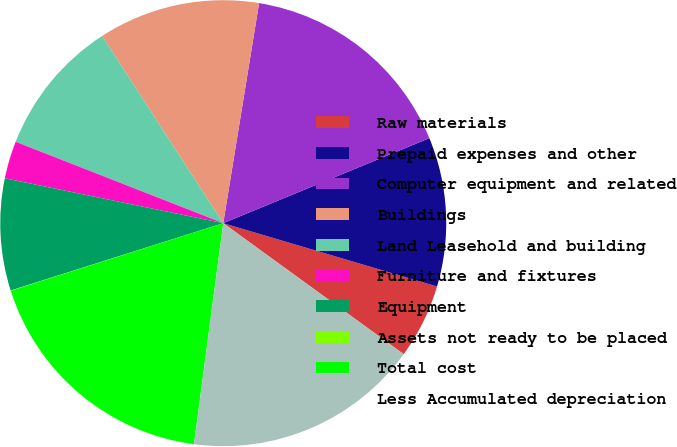<chart> <loc_0><loc_0><loc_500><loc_500><pie_chart><fcel>Raw materials<fcel>Prepaid expenses and other<fcel>Computer equipment and related<fcel>Buildings<fcel>Land Leasehold and building<fcel>Furniture and fixtures<fcel>Equipment<fcel>Assets not ready to be placed<fcel>Total cost<fcel>Less Accumulated depreciation<nl><fcel>5.41%<fcel>10.81%<fcel>16.2%<fcel>11.71%<fcel>9.91%<fcel>2.72%<fcel>8.11%<fcel>0.02%<fcel>18.0%<fcel>17.1%<nl></chart> 